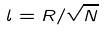<formula> <loc_0><loc_0><loc_500><loc_500>l = R / \sqrt { N }</formula> 